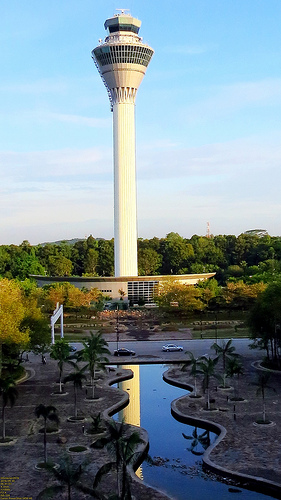<image>
Is there a tower behind the water? Yes. From this viewpoint, the tower is positioned behind the water, with the water partially or fully occluding the tower. 